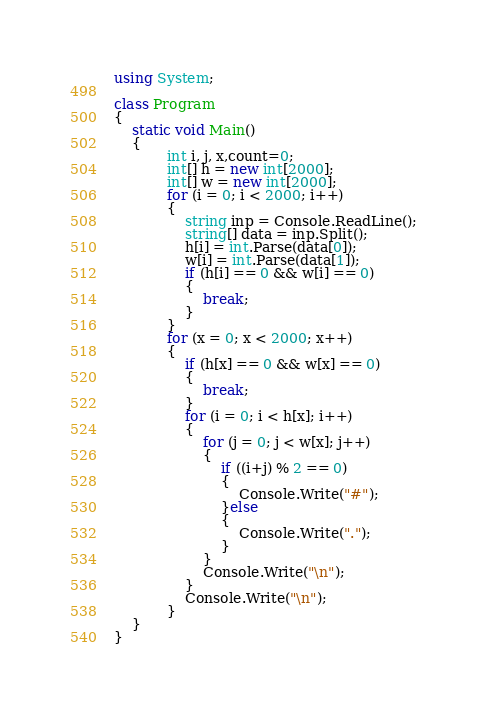<code> <loc_0><loc_0><loc_500><loc_500><_C#_>using System;

class Program
{
    static void Main()
    {
            int i, j, x,count=0;
            int[] h = new int[2000];
            int[] w = new int[2000];
            for (i = 0; i < 2000; i++)
            {
                string inp = Console.ReadLine();
                string[] data = inp.Split();
                h[i] = int.Parse(data[0]);
                w[i] = int.Parse(data[1]);
                if (h[i] == 0 && w[i] == 0)
                {
                    break;
                }
            }
            for (x = 0; x < 2000; x++)
            {
                if (h[x] == 0 && w[x] == 0)
                {
                    break;
                }
                for (i = 0; i < h[x]; i++)
                {
                    for (j = 0; j < w[x]; j++)
                    {
                        if ((i+j) % 2 == 0)
                        {
                            Console.Write("#");
                        }else
                        {
                            Console.Write(".");
                        }
                    }
                    Console.Write("\n");
                }
                Console.Write("\n");
            }
    }
}
</code> 